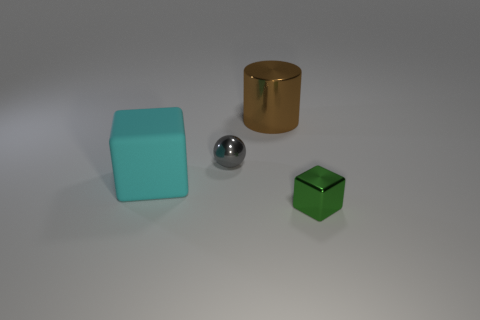There is a metallic cylinder; how many metallic objects are in front of it?
Make the answer very short. 2. There is a cube to the left of the green thing; is its size the same as the big brown metal thing?
Ensure brevity in your answer.  Yes. The other small thing that is the same shape as the cyan object is what color?
Offer a very short reply. Green. Is there any other thing that is the same shape as the tiny gray metal object?
Offer a very short reply. No. There is a small thing that is behind the green shiny cube; what shape is it?
Your answer should be compact. Sphere. What number of big cyan rubber things have the same shape as the small green thing?
Offer a terse response. 1. There is a block to the left of the metallic sphere; is its color the same as the small object in front of the cyan matte object?
Provide a short and direct response. No. How many things are either tiny brown cylinders or tiny things?
Your answer should be compact. 2. What number of big gray cylinders are made of the same material as the ball?
Offer a terse response. 0. Is the number of tiny purple objects less than the number of brown metal objects?
Provide a succinct answer. Yes. 